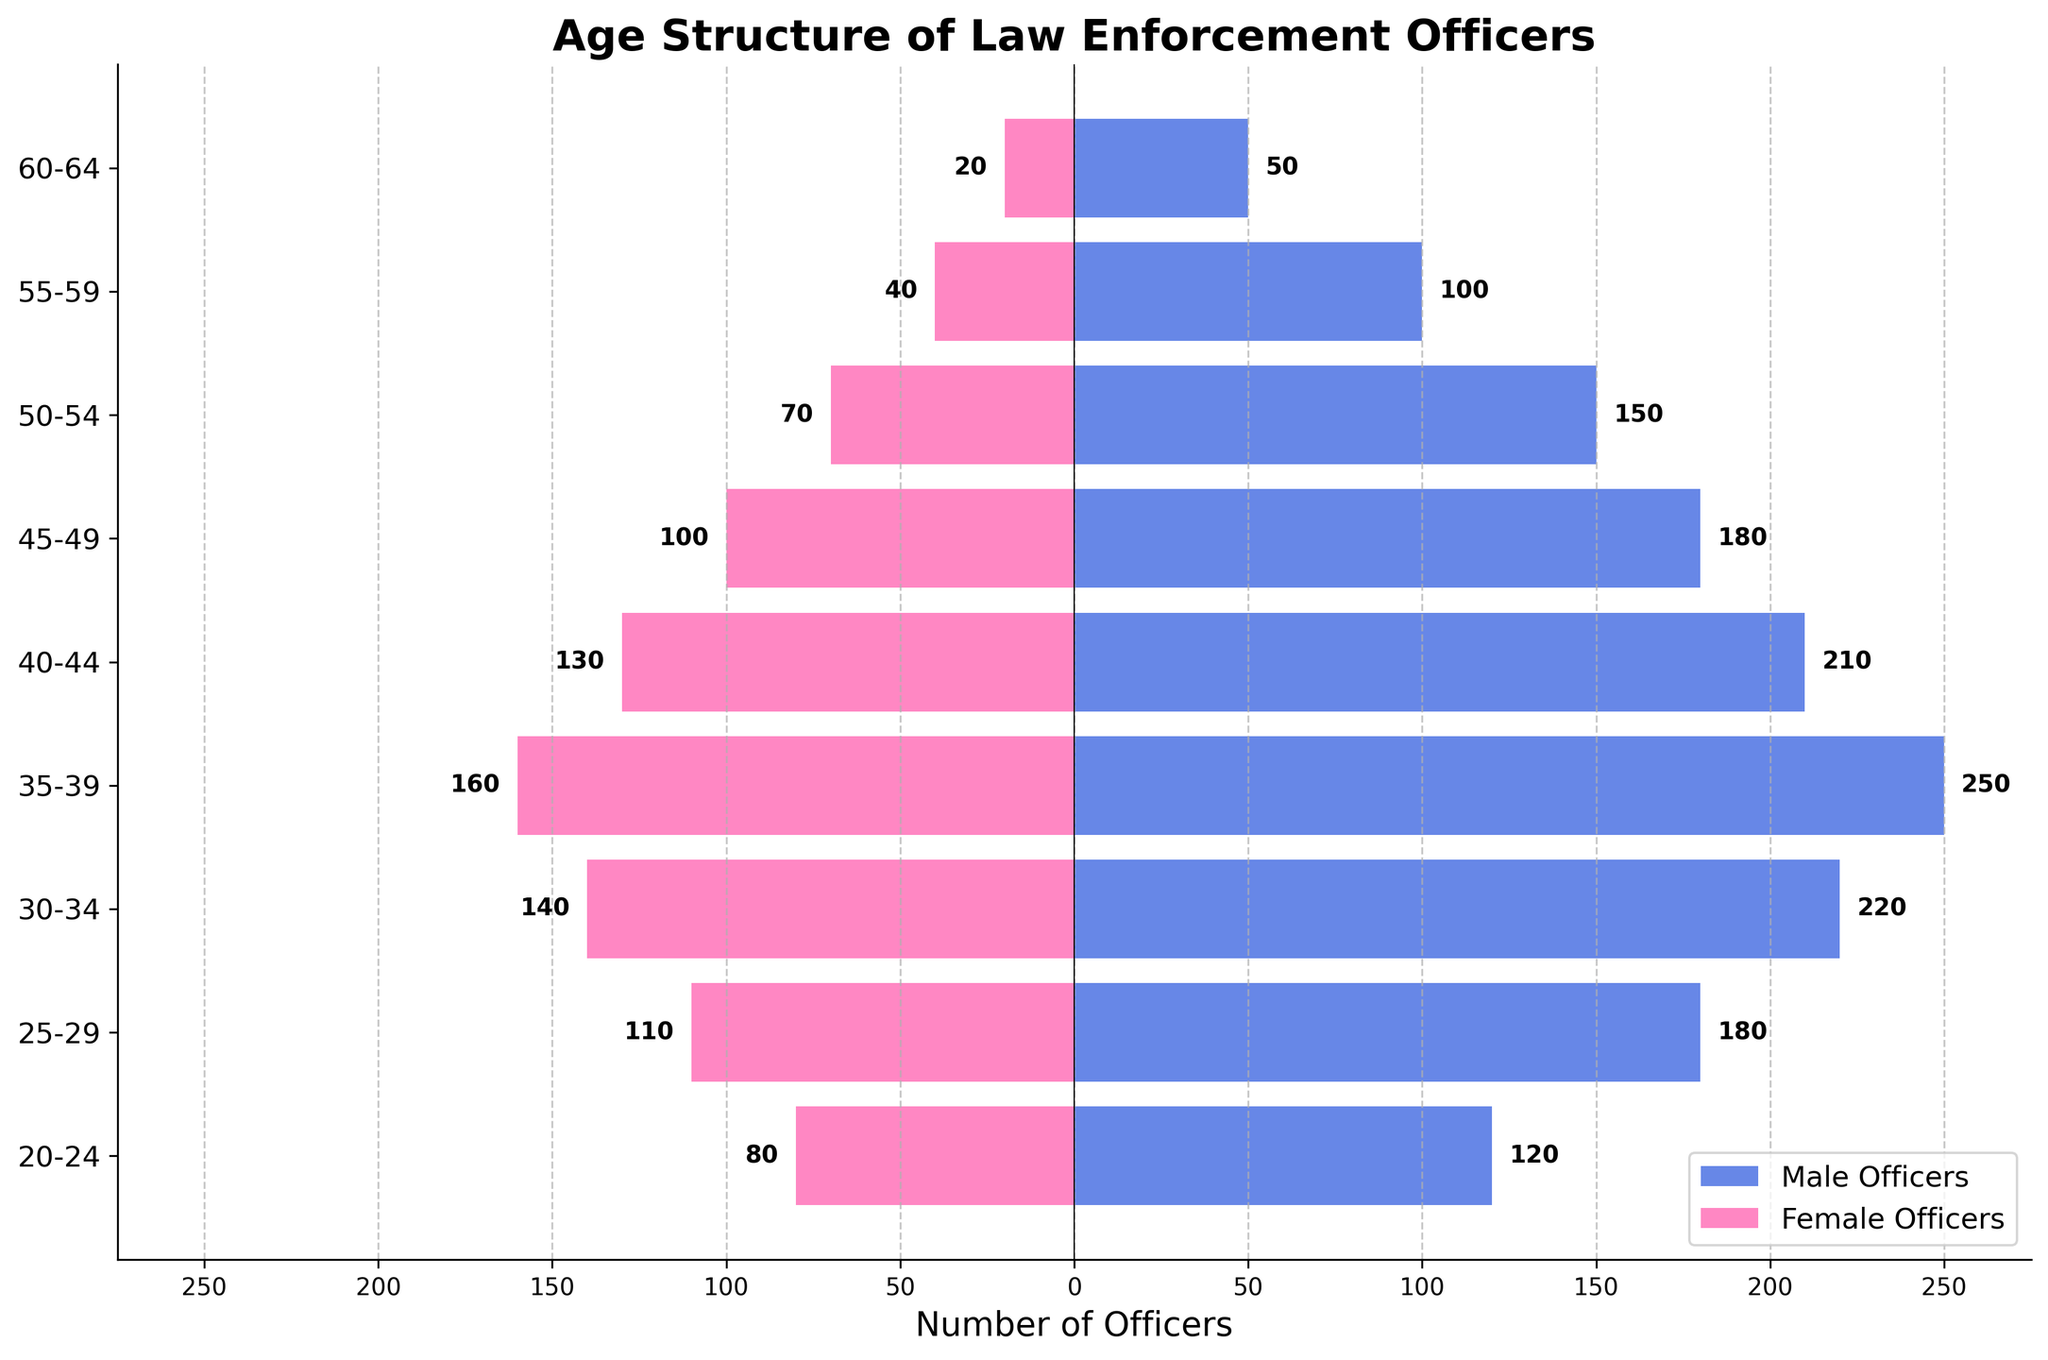What is the title of the figure? The title is generally at the top of the figure and gives an overview of the chart. The title for this figure is "Age Structure of Law Enforcement Officers."
Answer: Age Structure of Law Enforcement Officers What color represents male officers in the chart? By looking at the horizontal bars, we can identify that the color blue represents male officers.
Answer: Blue Which age group has the highest number of male officers? By comparing the lengths of the blue bars for each age group, the bar for the 35-39 age group is the longest.
Answer: 35-39 What is the number of female officers in the 30-34 age group? The pink bar to the left corresponding to the 30-34 age group has a length indicating 140 officers.
Answer: 140 How many more male officers are there than female officers in the 25-29 age group? The number of male officers is 180 and female officers is 110 in the 25-29 age group. The difference would be 180 - 110.
Answer: 70 Which age group has the fewest number of female officers? By examining the lengths of the pink bars, the 60-64 age group has the shortest bar indicating the fewest number of female officers.
Answer: 60-64 Compare the number of male officers aged 40-44 to those aged 45-49. The length of the blue bar for the 40-44 age group indicates 210 officers while for the 45-49 age group it shows 180 officers. So, 210 - 180 = 30 more officers in the 40-44 group.
Answer: 30 more in 40-44 Which age group has the smallest gender gap in terms of the number of officers? By visually comparing the relative lengths of the blue and pink bars for each age group, the 20-24 age group has 120 male and 80 female officers, a difference of 40. This is the smallest among all groups.
Answer: 20-24 What is the total number of female officers across all age groups? Adding the values: 80 (20-24) + 110 (25-29) + 140 (30-34) + 160 (35-39) + 130 (40-44) + 100 (45-49) + 70 (50-54) + 40 (55-59) + 20 (60-64) = 850.
Answer: 850 How does the number of male officers aged 50-54 compare to those aged 55-59? The blue bar shows 150 officers for the 50-54 age group and 100 officers for the 55-59 age group. Thus, 150 - 100 = 50 more officers in the 50-54 age group.
Answer: 50 more in 50-54 